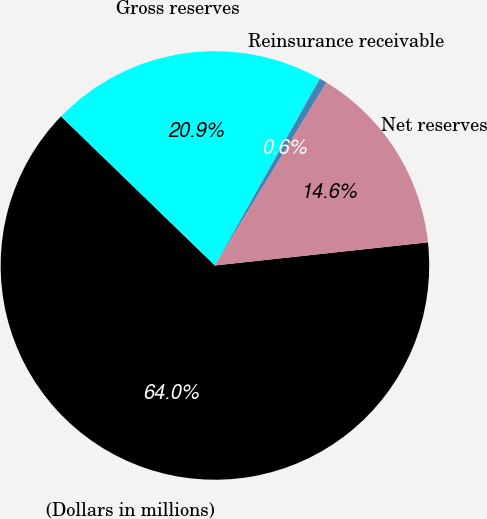Convert chart. <chart><loc_0><loc_0><loc_500><loc_500><pie_chart><fcel>(Dollars in millions)<fcel>Gross reserves<fcel>Reinsurance receivable<fcel>Net reserves<nl><fcel>63.98%<fcel>20.9%<fcel>0.57%<fcel>14.56%<nl></chart> 